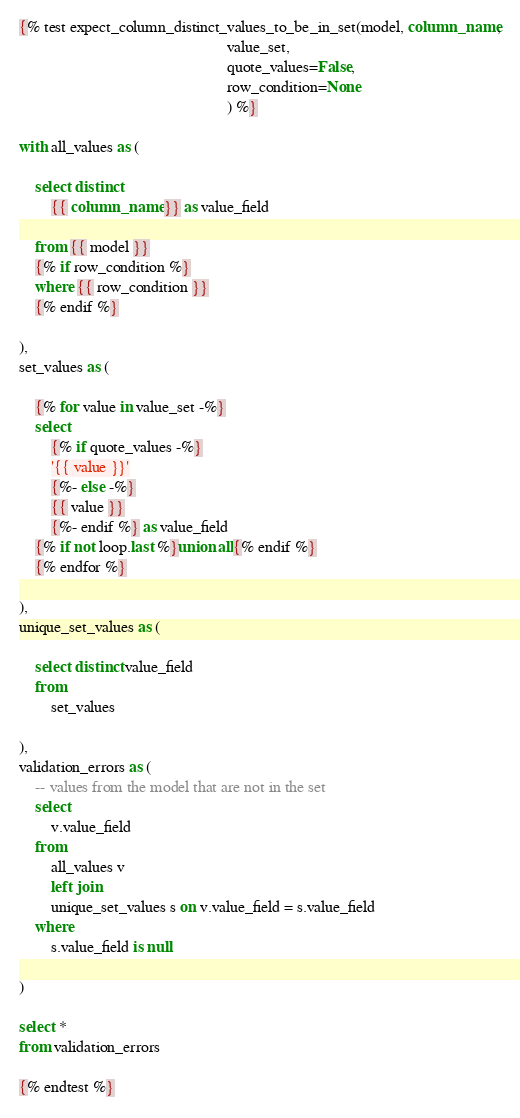<code> <loc_0><loc_0><loc_500><loc_500><_SQL_>{% test expect_column_distinct_values_to_be_in_set(model, column_name,
                                                    value_set,
                                                    quote_values=False,
                                                    row_condition=None
                                                    ) %}

with all_values as (

    select distinct
        {{ column_name }} as value_field

    from {{ model }}
    {% if row_condition %}
    where {{ row_condition }}
    {% endif %}

),
set_values as (

    {% for value in value_set -%}
    select
        {% if quote_values -%}
        '{{ value }}'
        {%- else -%}
        {{ value }}
        {%- endif %} as value_field
    {% if not loop.last %}union all{% endif %}
    {% endfor %}

),
unique_set_values as (

    select distinct value_field
    from
        set_values

),
validation_errors as (
    -- values from the model that are not in the set
    select
        v.value_field
    from
        all_values v
        left join
        unique_set_values s on v.value_field = s.value_field
    where
        s.value_field is null

)

select *
from validation_errors

{% endtest %}
</code> 